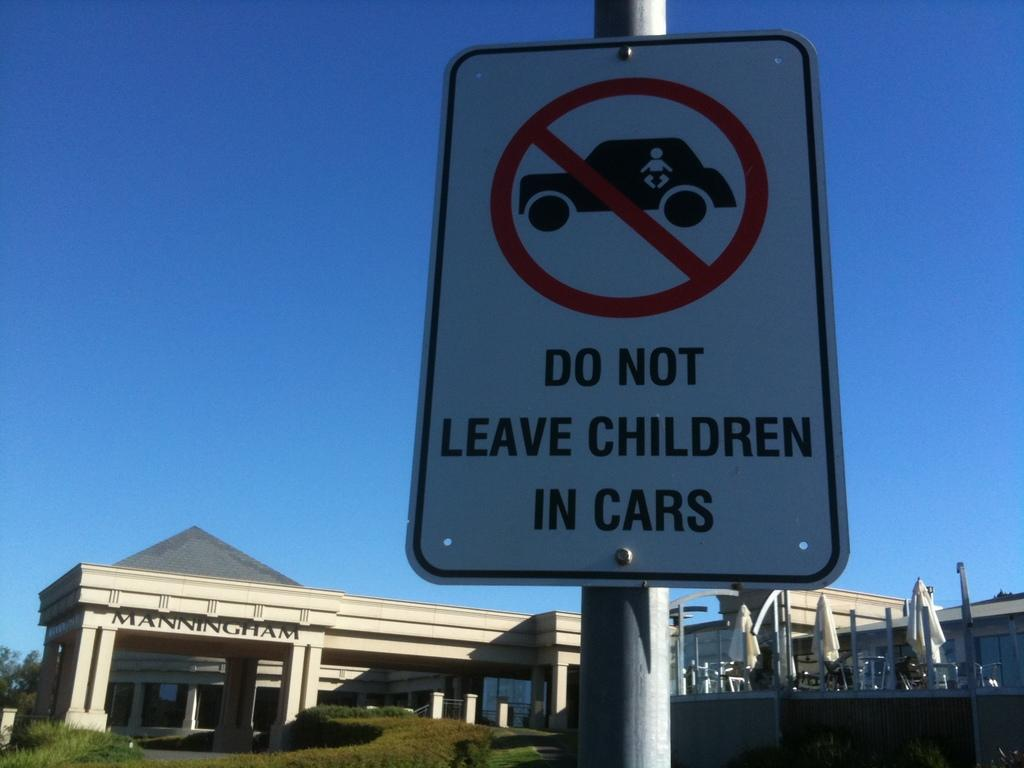<image>
Summarize the visual content of the image. A sign asking passers by not to leave children in cars. 